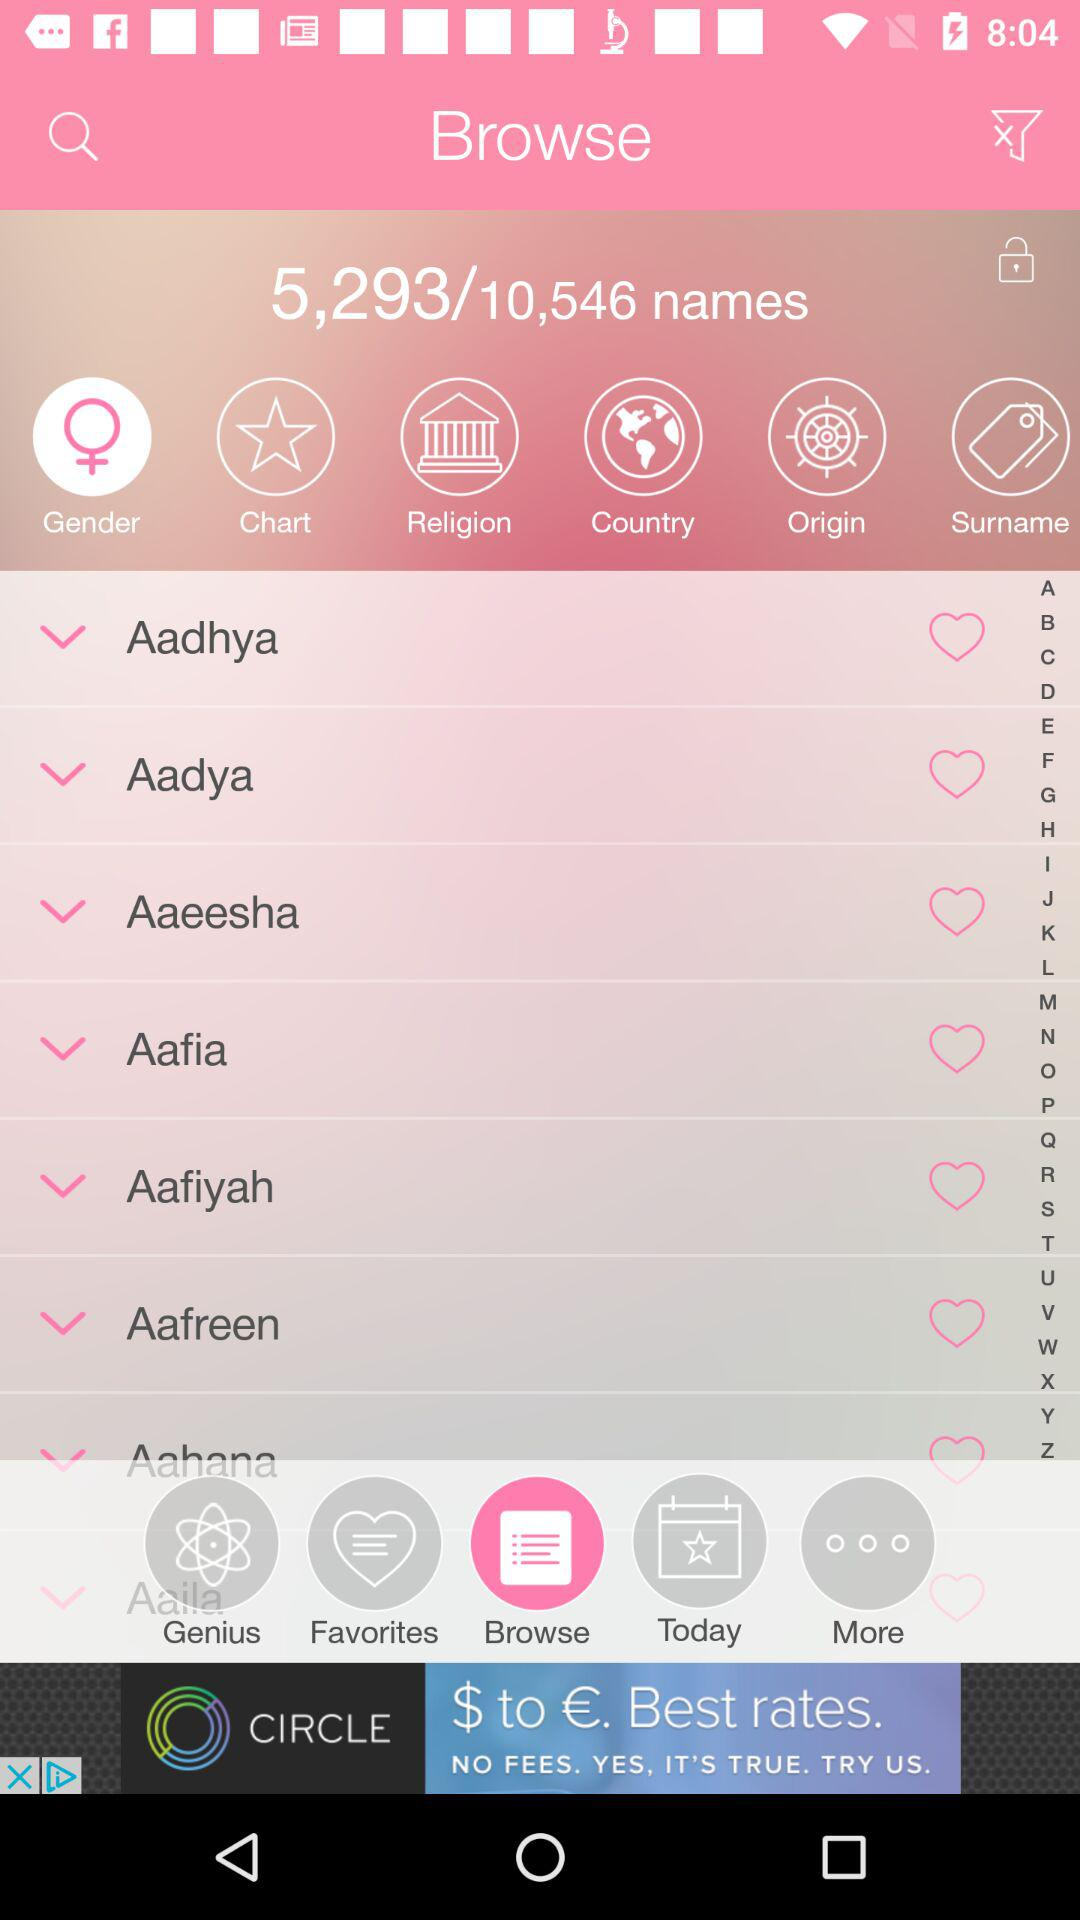Which option is selected in the tab bar? The selected option is "Browse". 